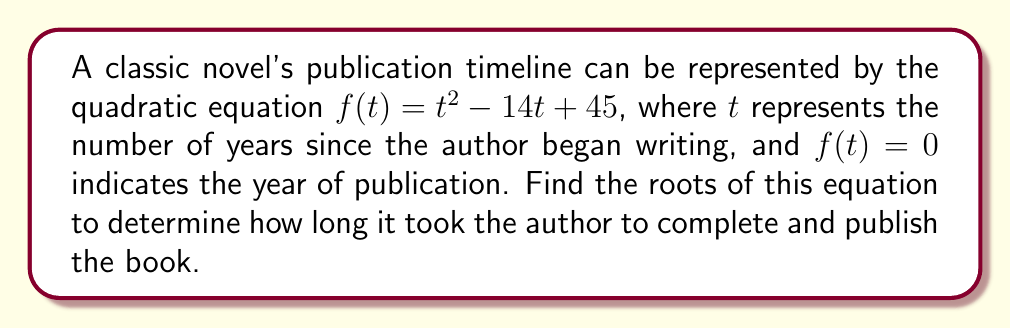Help me with this question. To find the roots of the quadratic equation, we'll use the quadratic formula:

$$x = \frac{-b \pm \sqrt{b^2 - 4ac}}{2a}$$

Where $a = 1$, $b = -14$, and $c = 45$.

Step 1: Substitute the values into the quadratic formula:
$$t = \frac{-(-14) \pm \sqrt{(-14)^2 - 4(1)(45)}}{2(1)}$$

Step 2: Simplify under the square root:
$$t = \frac{14 \pm \sqrt{196 - 180}}{2}$$
$$t = \frac{14 \pm \sqrt{16}}{2}$$
$$t = \frac{14 \pm 4}{2}$$

Step 3: Calculate the two roots:
$$t_1 = \frac{14 + 4}{2} = \frac{18}{2} = 9$$
$$t_2 = \frac{14 - 4}{2} = \frac{10}{2} = 5$$

The roots are 9 and 5, meaning it took the author 9 years to complete and publish the book, and they began writing 5 years before publication.
Answer: $t = 9$ years and $t = 5$ years 